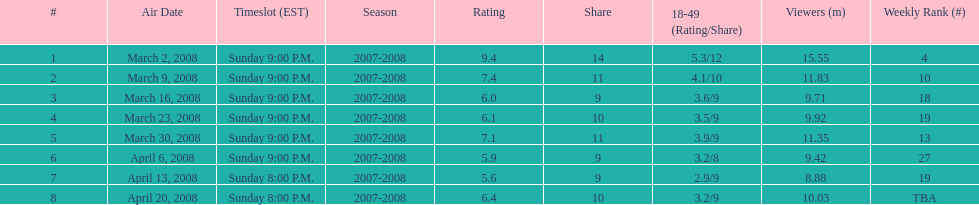Which episode received the top rating? March 2, 2008. 